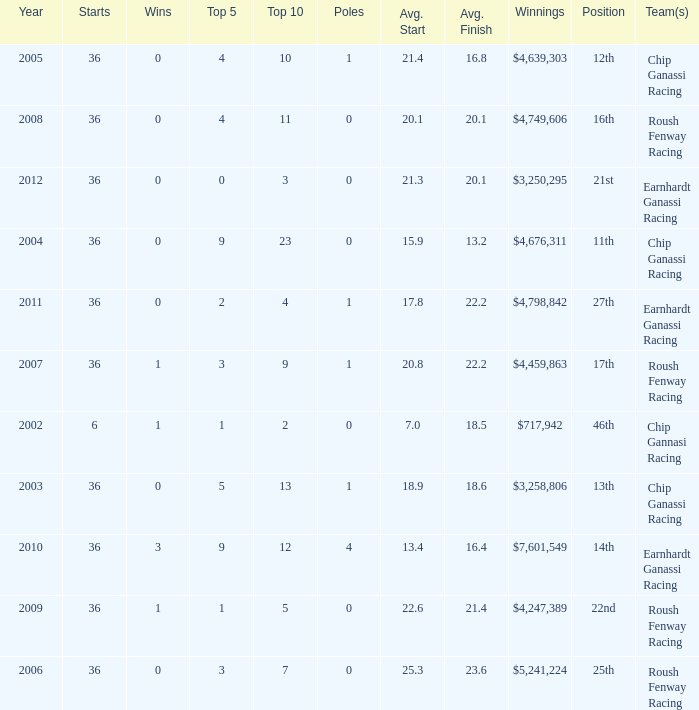Name the poles for 25th position 0.0. Could you parse the entire table? {'header': ['Year', 'Starts', 'Wins', 'Top 5', 'Top 10', 'Poles', 'Avg. Start', 'Avg. Finish', 'Winnings', 'Position', 'Team(s)'], 'rows': [['2005', '36', '0', '4', '10', '1', '21.4', '16.8', '$4,639,303', '12th', 'Chip Ganassi Racing'], ['2008', '36', '0', '4', '11', '0', '20.1', '20.1', '$4,749,606', '16th', 'Roush Fenway Racing'], ['2012', '36', '0', '0', '3', '0', '21.3', '20.1', '$3,250,295', '21st', 'Earnhardt Ganassi Racing'], ['2004', '36', '0', '9', '23', '0', '15.9', '13.2', '$4,676,311', '11th', 'Chip Ganassi Racing'], ['2011', '36', '0', '2', '4', '1', '17.8', '22.2', '$4,798,842', '27th', 'Earnhardt Ganassi Racing'], ['2007', '36', '1', '3', '9', '1', '20.8', '22.2', '$4,459,863', '17th', 'Roush Fenway Racing'], ['2002', '6', '1', '1', '2', '0', '7.0', '18.5', '$717,942', '46th', 'Chip Gannasi Racing'], ['2003', '36', '0', '5', '13', '1', '18.9', '18.6', '$3,258,806', '13th', 'Chip Ganassi Racing'], ['2010', '36', '3', '9', '12', '4', '13.4', '16.4', '$7,601,549', '14th', 'Earnhardt Ganassi Racing'], ['2009', '36', '1', '1', '5', '0', '22.6', '21.4', '$4,247,389', '22nd', 'Roush Fenway Racing'], ['2006', '36', '0', '3', '7', '0', '25.3', '23.6', '$5,241,224', '25th', 'Roush Fenway Racing']]} 